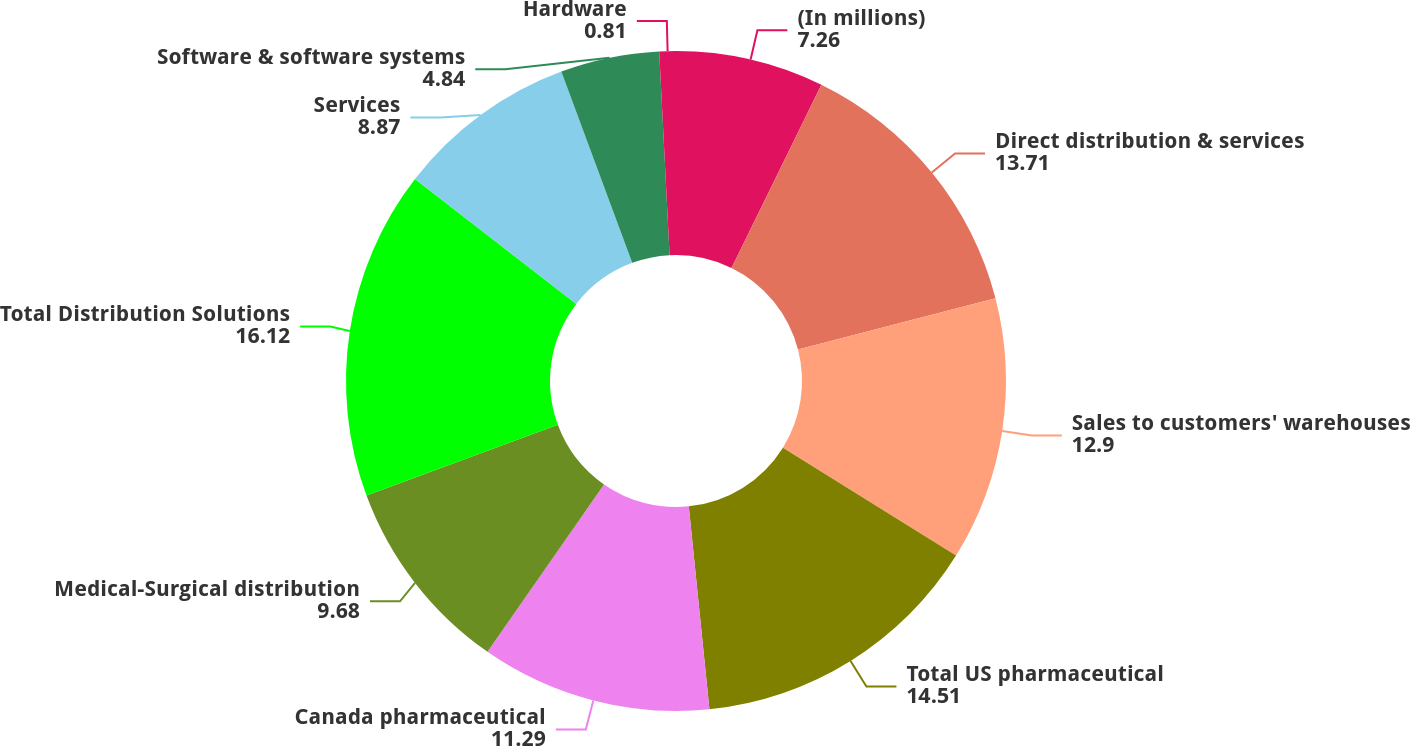<chart> <loc_0><loc_0><loc_500><loc_500><pie_chart><fcel>(In millions)<fcel>Direct distribution & services<fcel>Sales to customers' warehouses<fcel>Total US pharmaceutical<fcel>Canada pharmaceutical<fcel>Medical-Surgical distribution<fcel>Total Distribution Solutions<fcel>Services<fcel>Software & software systems<fcel>Hardware<nl><fcel>7.26%<fcel>13.71%<fcel>12.9%<fcel>14.51%<fcel>11.29%<fcel>9.68%<fcel>16.12%<fcel>8.87%<fcel>4.84%<fcel>0.81%<nl></chart> 